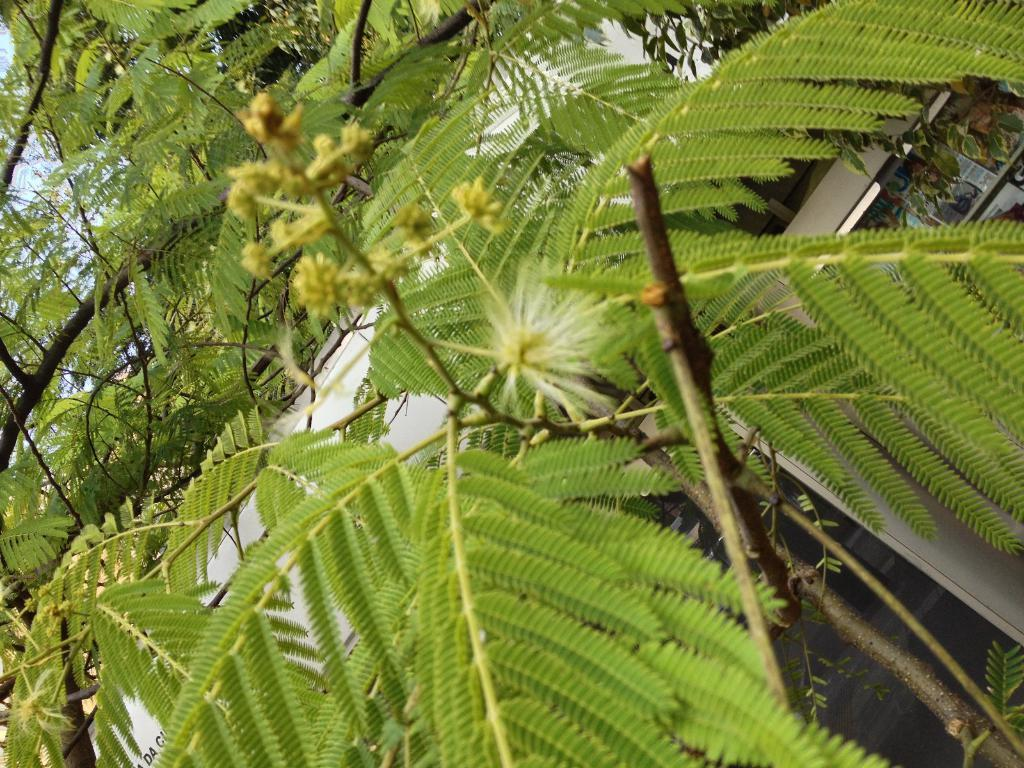What type of vegetation can be seen in the image? There are trees in the image. What structure is visible in the background of the image? There appears to be a building in the background of the image. What color is the sky in the image? The sky is blue in color. How many oranges are hanging from the trees in the image? There are no oranges visible in the image; only trees are present. What type of mine is depicted in the image? There is no mine present in the image. 